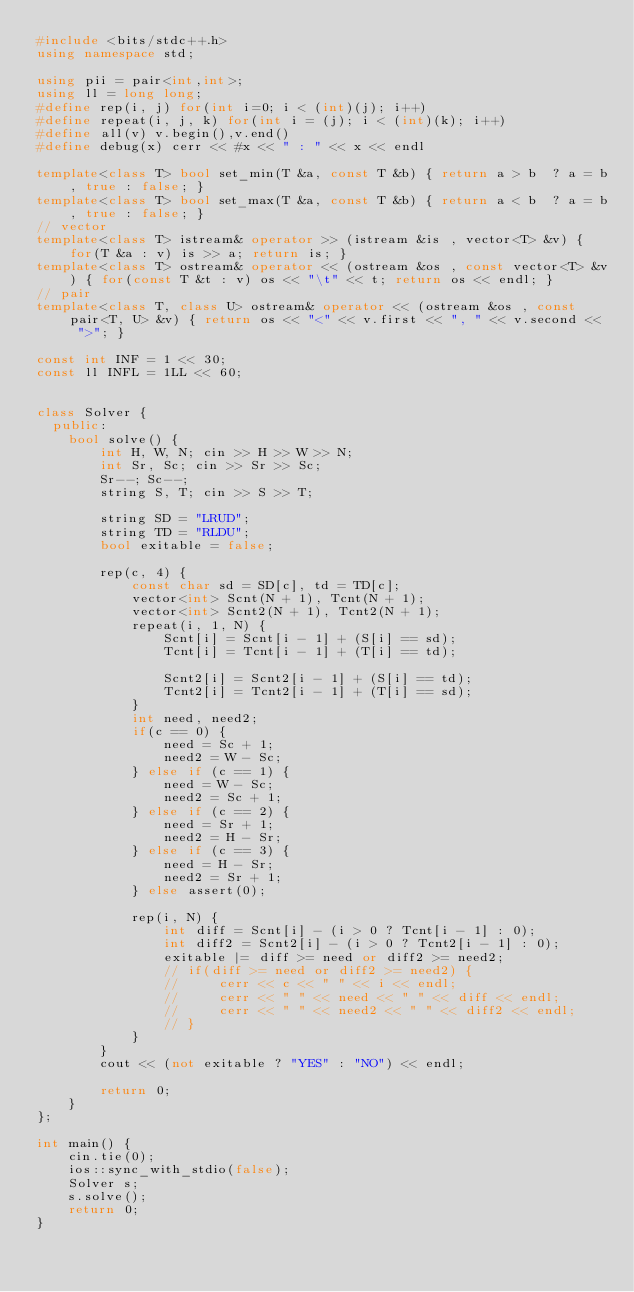<code> <loc_0><loc_0><loc_500><loc_500><_C++_>#include <bits/stdc++.h>
using namespace std;

using pii = pair<int,int>;
using ll = long long;
#define rep(i, j) for(int i=0; i < (int)(j); i++)
#define repeat(i, j, k) for(int i = (j); i < (int)(k); i++)
#define all(v) v.begin(),v.end()
#define debug(x) cerr << #x << " : " << x << endl

template<class T> bool set_min(T &a, const T &b) { return a > b  ? a = b, true : false; }
template<class T> bool set_max(T &a, const T &b) { return a < b  ? a = b, true : false; }
// vector
template<class T> istream& operator >> (istream &is , vector<T> &v) { for(T &a : v) is >> a; return is; }
template<class T> ostream& operator << (ostream &os , const vector<T> &v) { for(const T &t : v) os << "\t" << t; return os << endl; }
// pair
template<class T, class U> ostream& operator << (ostream &os , const pair<T, U> &v) { return os << "<" << v.first << ", " << v.second << ">"; }

const int INF = 1 << 30;
const ll INFL = 1LL << 60;


class Solver {
  public:
    bool solve() {
        int H, W, N; cin >> H >> W >> N;
        int Sr, Sc; cin >> Sr >> Sc;
        Sr--; Sc--;
        string S, T; cin >> S >> T;

        string SD = "LRUD";
        string TD = "RLDU";
        bool exitable = false;

        rep(c, 4) {
            const char sd = SD[c], td = TD[c];
            vector<int> Scnt(N + 1), Tcnt(N + 1);
            vector<int> Scnt2(N + 1), Tcnt2(N + 1);
            repeat(i, 1, N) {
                Scnt[i] = Scnt[i - 1] + (S[i] == sd);
                Tcnt[i] = Tcnt[i - 1] + (T[i] == td);

                Scnt2[i] = Scnt2[i - 1] + (S[i] == td);
                Tcnt2[i] = Tcnt2[i - 1] + (T[i] == sd);
            }
            int need, need2;
            if(c == 0) {
                need = Sc + 1;
                need2 = W - Sc;
            } else if (c == 1) {
                need = W - Sc;
                need2 = Sc + 1;
            } else if (c == 2) {
                need = Sr + 1;
                need2 = H - Sr;
            } else if (c == 3) {
                need = H - Sr;
                need2 = Sr + 1;
            } else assert(0);

            rep(i, N) {
                int diff = Scnt[i] - (i > 0 ? Tcnt[i - 1] : 0);
                int diff2 = Scnt2[i] - (i > 0 ? Tcnt2[i - 1] : 0);
                exitable |= diff >= need or diff2 >= need2;
                // if(diff >= need or diff2 >= need2) {
                //     cerr << c << " " << i << endl;
                //     cerr << " " << need << " " << diff << endl;
                //     cerr << " " << need2 << " " << diff2 << endl;
                // }
            }
        }
        cout << (not exitable ? "YES" : "NO") << endl;

        return 0;
    }
};

int main() {
    cin.tie(0);
    ios::sync_with_stdio(false);
    Solver s;
    s.solve();
    return 0;
}
</code> 